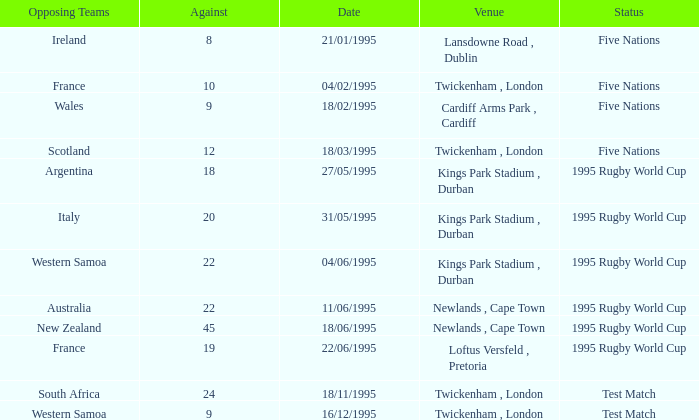When did the status test match take place against a team from south africa? 18/11/1995. 